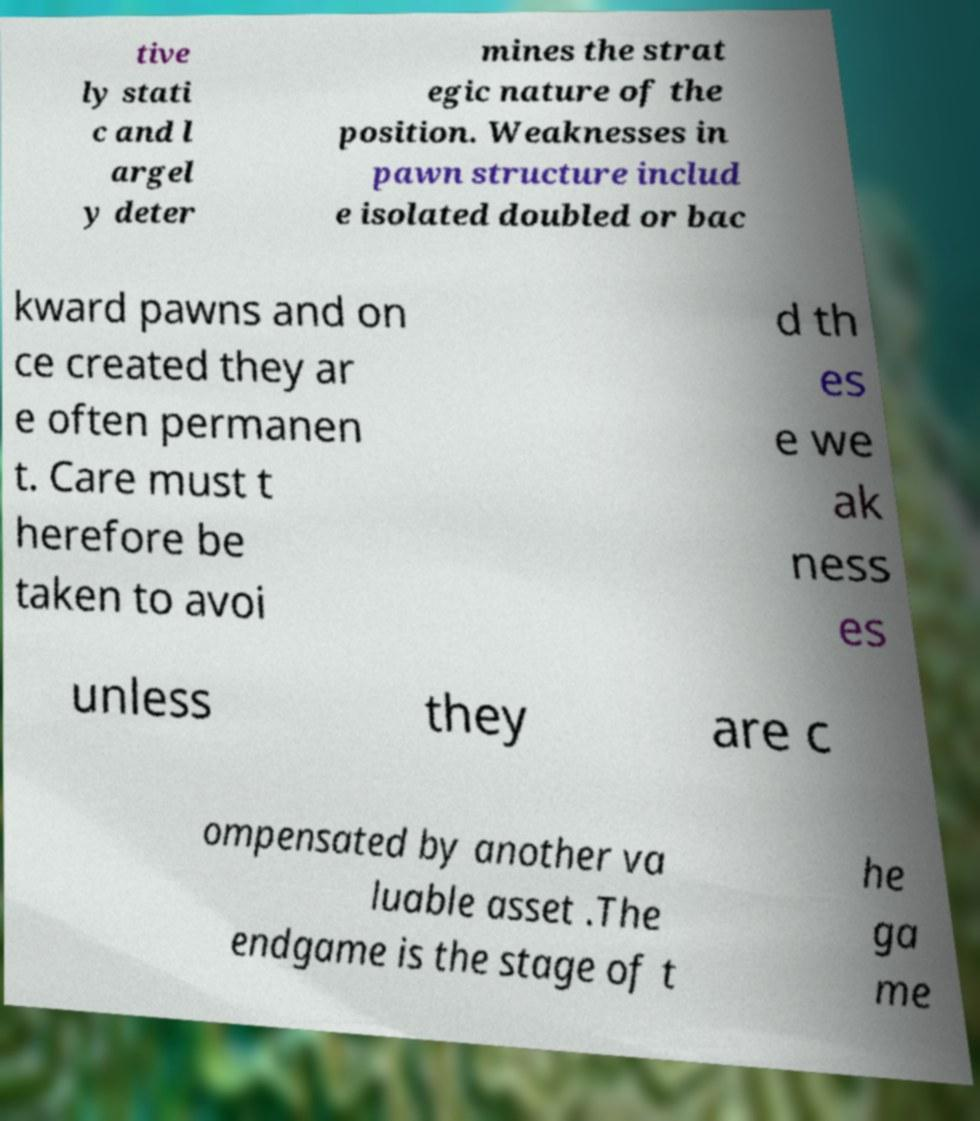Please read and relay the text visible in this image. What does it say? tive ly stati c and l argel y deter mines the strat egic nature of the position. Weaknesses in pawn structure includ e isolated doubled or bac kward pawns and on ce created they ar e often permanen t. Care must t herefore be taken to avoi d th es e we ak ness es unless they are c ompensated by another va luable asset .The endgame is the stage of t he ga me 